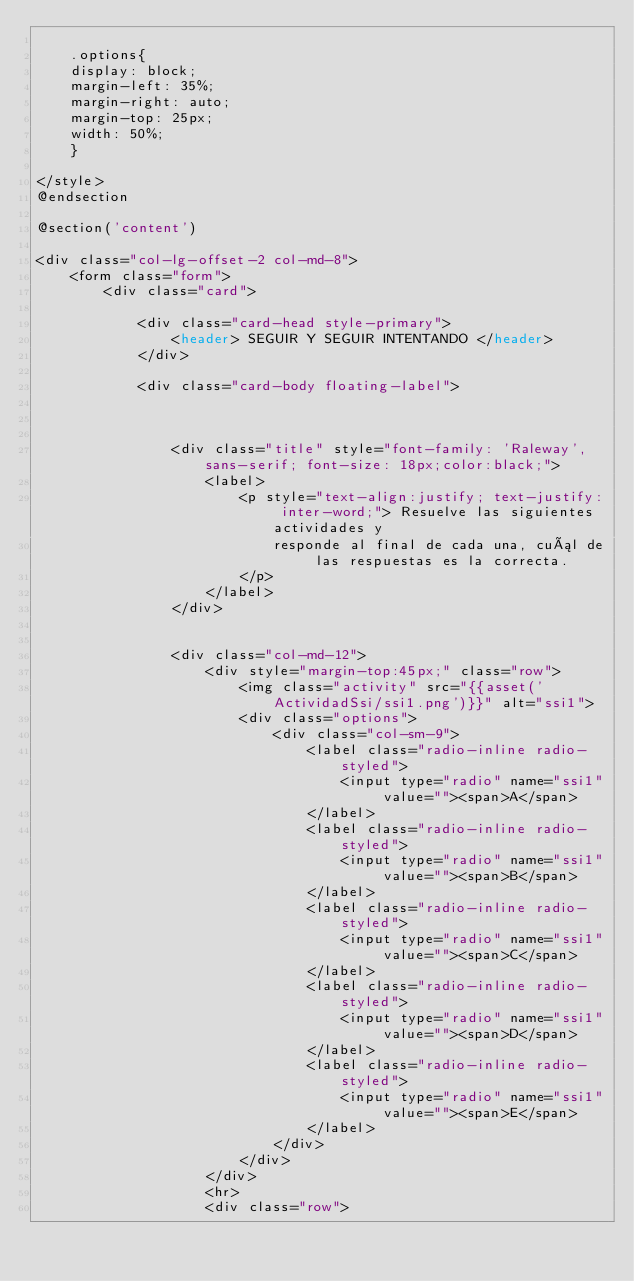Convert code to text. <code><loc_0><loc_0><loc_500><loc_500><_PHP_>
    .options{
    display: block;
    margin-left: 35%;
    margin-right: auto;
    margin-top: 25px;
    width: 50%;
    }

</style>
@endsection

@section('content')

<div class="col-lg-offset-2 col-md-8">
    <form class="form">
        <div class="card">

            <div class="card-head style-primary">
                <header> SEGUIR Y SEGUIR INTENTANDO </header>
            </div>

            <div class="card-body floating-label">



                <div class="title" style="font-family: 'Raleway', sans-serif; font-size: 18px;color:black;">
                    <label>
                        <p style="text-align:justify; text-justify: inter-word;"> Resuelve las siguientes actividades y
                            responde al final de cada una, cuál de las respuestas es la correcta.
                        </p>
                    </label>
                </div>


                <div class="col-md-12">
                    <div style="margin-top:45px;" class="row">
                        <img class="activity" src="{{asset('ActividadSsi/ssi1.png')}}" alt="ssi1">
                        <div class="options">
                            <div class="col-sm-9">
                                <label class="radio-inline radio-styled">
                                    <input type="radio" name="ssi1" value=""><span>A</span>
                                </label>
                                <label class="radio-inline radio-styled">
                                    <input type="radio" name="ssi1" value=""><span>B</span>
                                </label>
                                <label class="radio-inline radio-styled">
                                    <input type="radio" name="ssi1" value=""><span>C</span>
                                </label>
                                <label class="radio-inline radio-styled">
                                    <input type="radio" name="ssi1" value=""><span>D</span>
                                </label>
                                <label class="radio-inline radio-styled">
                                    <input type="radio" name="ssi1" value=""><span>E</span>
                                </label>
                            </div>
                        </div>
                    </div>
                    <hr>
                    <div class="row"></code> 